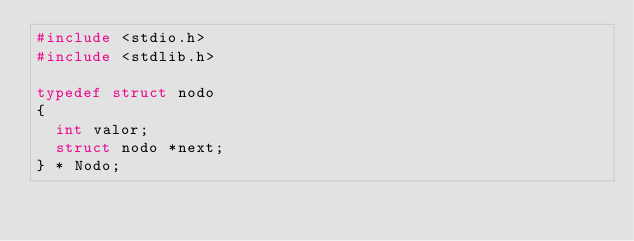Convert code to text. <code><loc_0><loc_0><loc_500><loc_500><_C_>#include <stdio.h>
#include <stdlib.h>

typedef struct nodo
{
  int valor;
  struct nodo *next;
} * Nodo;</code> 